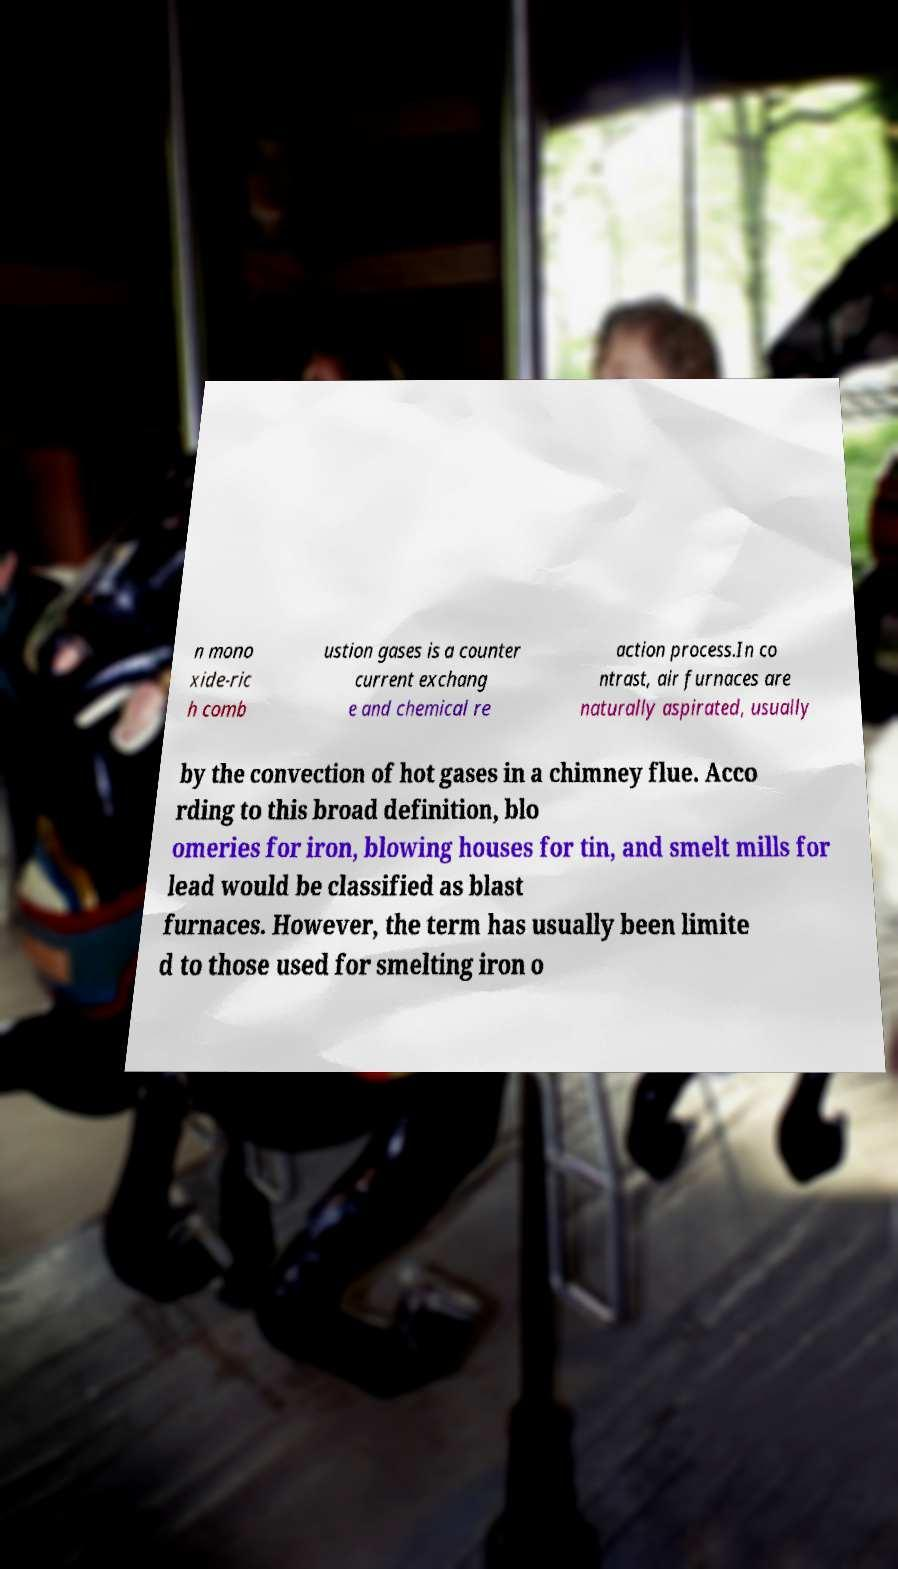Can you accurately transcribe the text from the provided image for me? n mono xide-ric h comb ustion gases is a counter current exchang e and chemical re action process.In co ntrast, air furnaces are naturally aspirated, usually by the convection of hot gases in a chimney flue. Acco rding to this broad definition, blo omeries for iron, blowing houses for tin, and smelt mills for lead would be classified as blast furnaces. However, the term has usually been limite d to those used for smelting iron o 